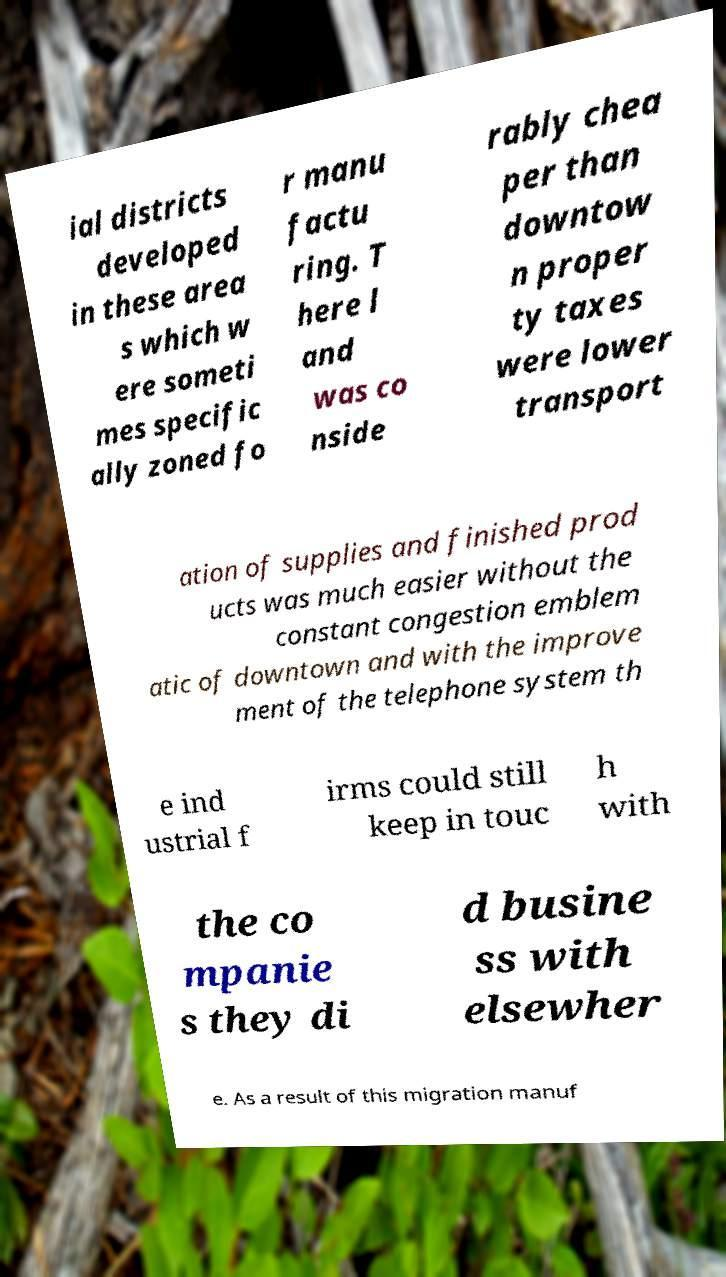There's text embedded in this image that I need extracted. Can you transcribe it verbatim? ial districts developed in these area s which w ere someti mes specific ally zoned fo r manu factu ring. T here l and was co nside rably chea per than downtow n proper ty taxes were lower transport ation of supplies and finished prod ucts was much easier without the constant congestion emblem atic of downtown and with the improve ment of the telephone system th e ind ustrial f irms could still keep in touc h with the co mpanie s they di d busine ss with elsewher e. As a result of this migration manuf 